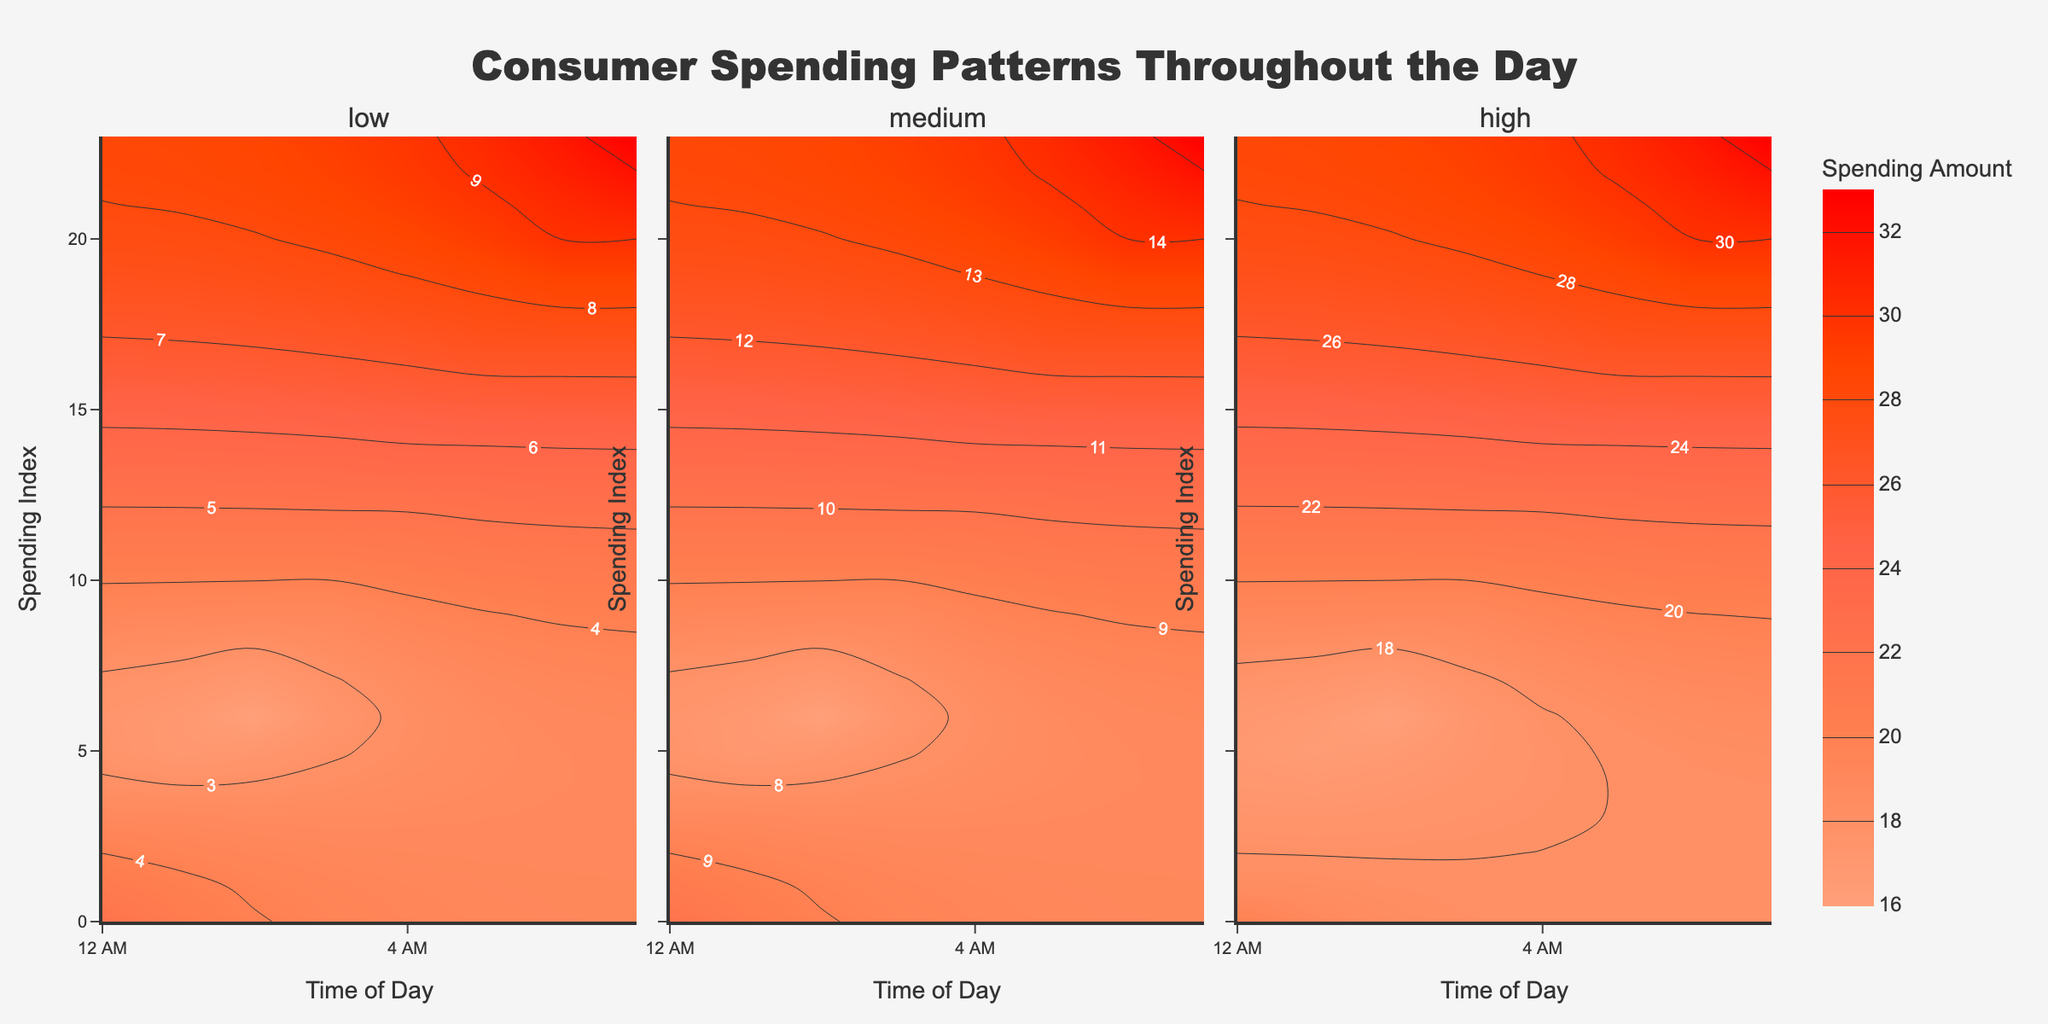What is the title of the figure? The title is located at the top center of the figure and provides a summary of what the visual represents. It is "Consumer Spending Patterns Throughout the Day".
Answer: Consumer Spending Patterns Throughout the Day Which income level subplot shows the highest spending amount during the day? By examining the color intensity in the subplots, the high-income level subplot shows the highest spending amount as it reaches the darkest color, indicating a spending amount of around 33 in the late evening.
Answer: High income At what specific time do low-income consumers spend the most? Look for the highest color intensity in the low-income level subplot. The spending amount is the most intense around 22:00.
Answer: 22:00 (10 PM) What is the general trend in spending amount for medium-income consumers from morning to evening? By observing the color gradient in the medium-income subplot, it’s noticeable that the spending amount starts lower in the morning and gradually increases throughout the day.
Answer: Increasing trend Compare the spending amount at 12:00 for all income levels. Which level has the highest spending and what is that amount? Examine the plots at 12:00. The high-income subplot shows the highest spending amount, reaching a value of 22.
Answer: High income, 22 How do the spending patterns of low-income and high-income consumers differ? By comparing the low-income and high-income subplots, we see that low-income consumers have relatively lower spending and less variation throughout the day, while high-income consumers have higher spending with more noticeable peaks.
Answer: Low-income stable, high-income peaks In which time segment (morning, afternoon, evening) is the gap between medium and high-income spending the largest? Evaluating the differences in spending amounts across subplots, the evening segment (18:00-23:00) shows the largest gap, where high-income spending is significantly higher than medium income.
Answer: Evening What is the average spending amount for medium-income consumers at 14:00 and 16:00? The spending amounts at 14:00 and 16:00 for medium-income are 11.0 and 12.0 respectively. The average is calculated as (11.0 + 12.0) / 2 = 11.5.
Answer: 11.5 